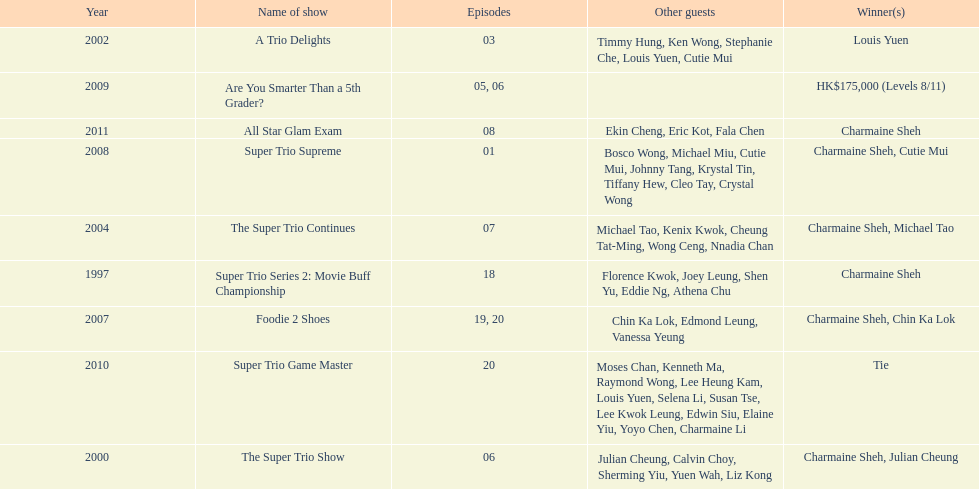How many episodes was charmaine sheh on in the variety show super trio 2: movie buff champions 18. 